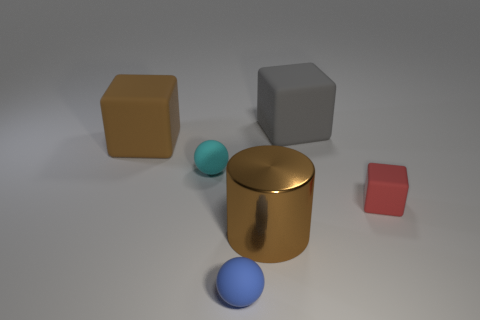Add 1 blue metallic cylinders. How many objects exist? 7 Subtract all big gray matte cubes. How many cubes are left? 2 Subtract all cylinders. How many objects are left? 5 Subtract 1 brown blocks. How many objects are left? 5 Subtract all green blocks. Subtract all gray spheres. How many blocks are left? 3 Subtract all large brown objects. Subtract all small red matte things. How many objects are left? 3 Add 1 gray blocks. How many gray blocks are left? 2 Add 3 cyan things. How many cyan things exist? 4 